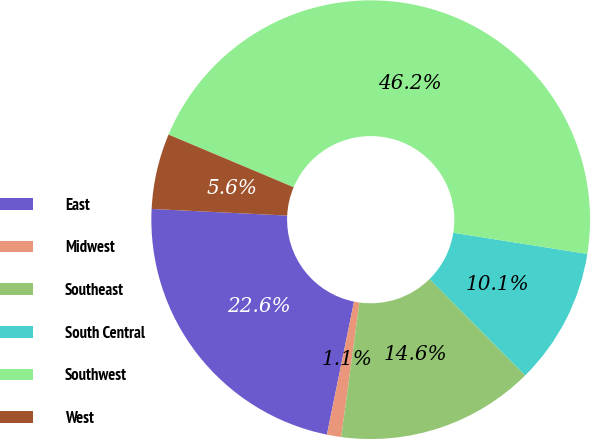<chart> <loc_0><loc_0><loc_500><loc_500><pie_chart><fcel>East<fcel>Midwest<fcel>Southeast<fcel>South Central<fcel>Southwest<fcel>West<nl><fcel>22.58%<fcel>1.05%<fcel>14.58%<fcel>10.07%<fcel>46.15%<fcel>5.56%<nl></chart> 